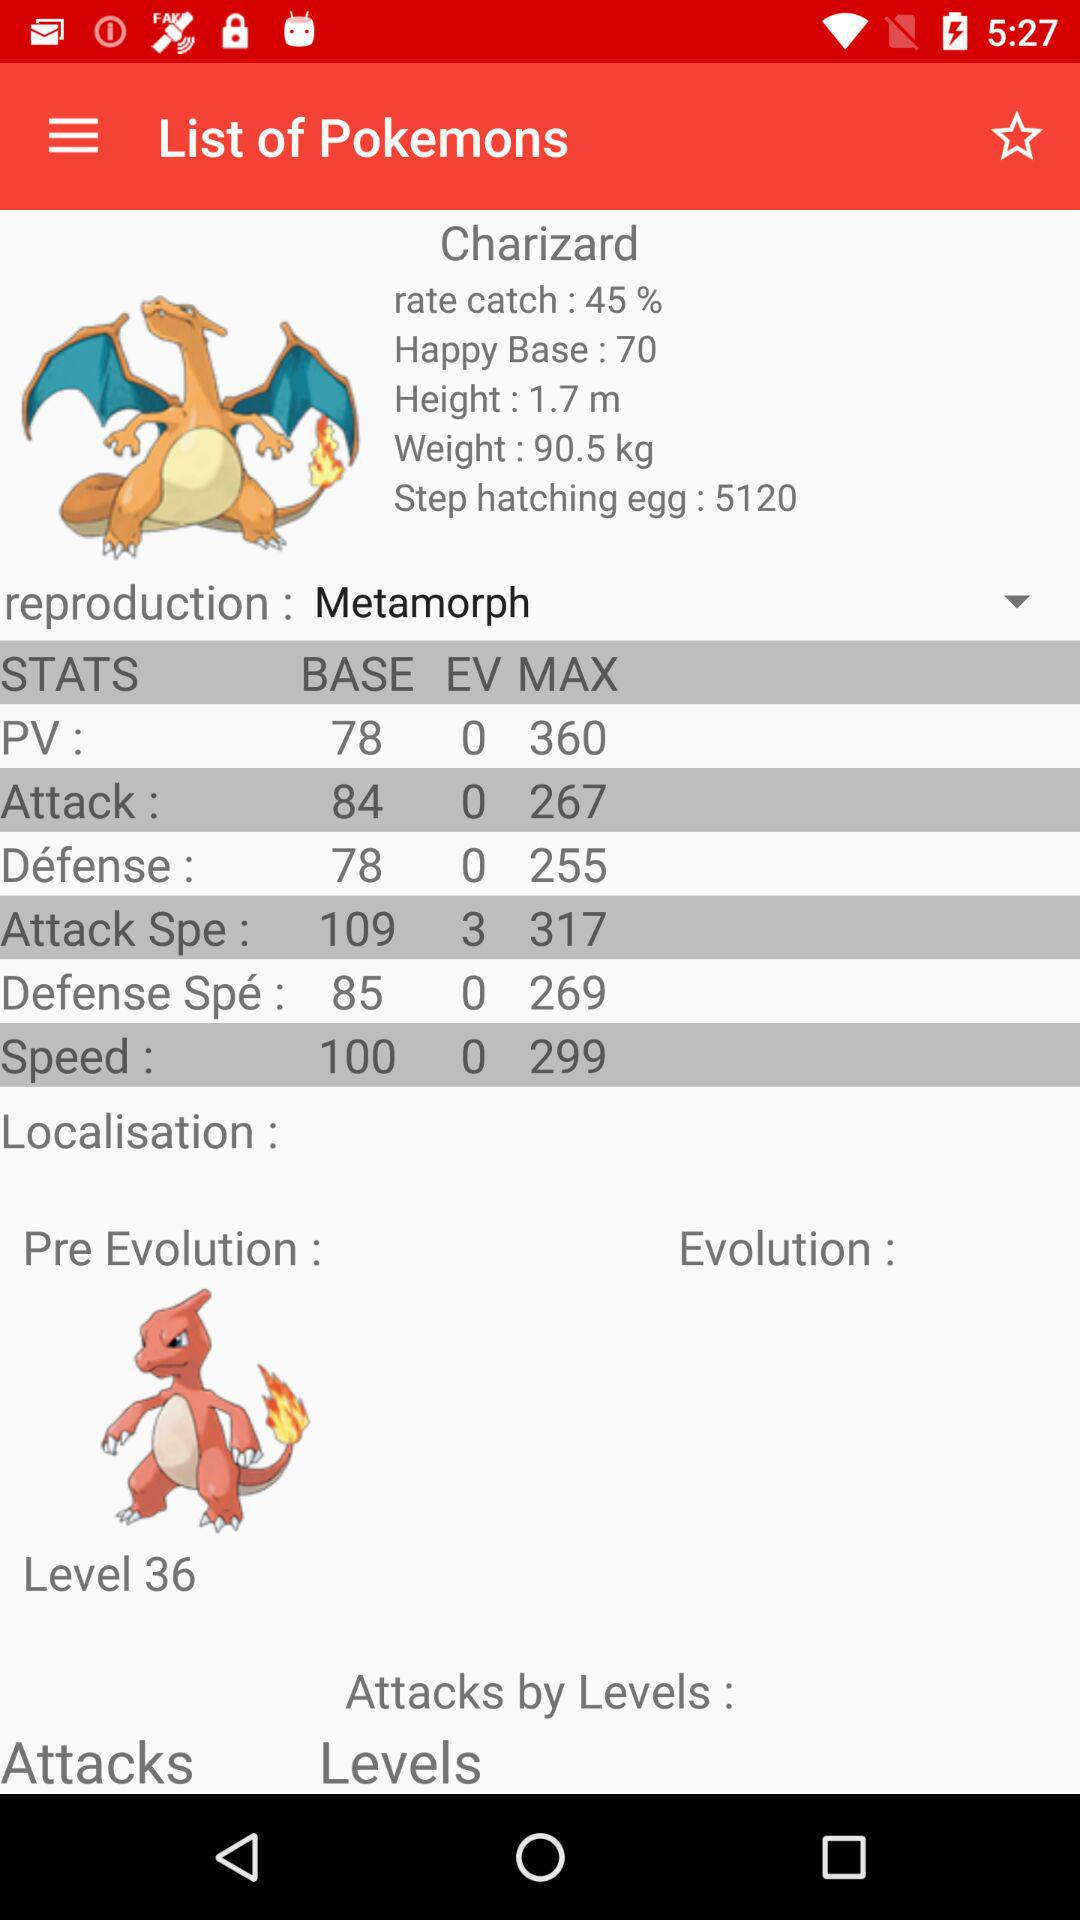What's the maximum attack speed? The maximum attack speed is 317. 